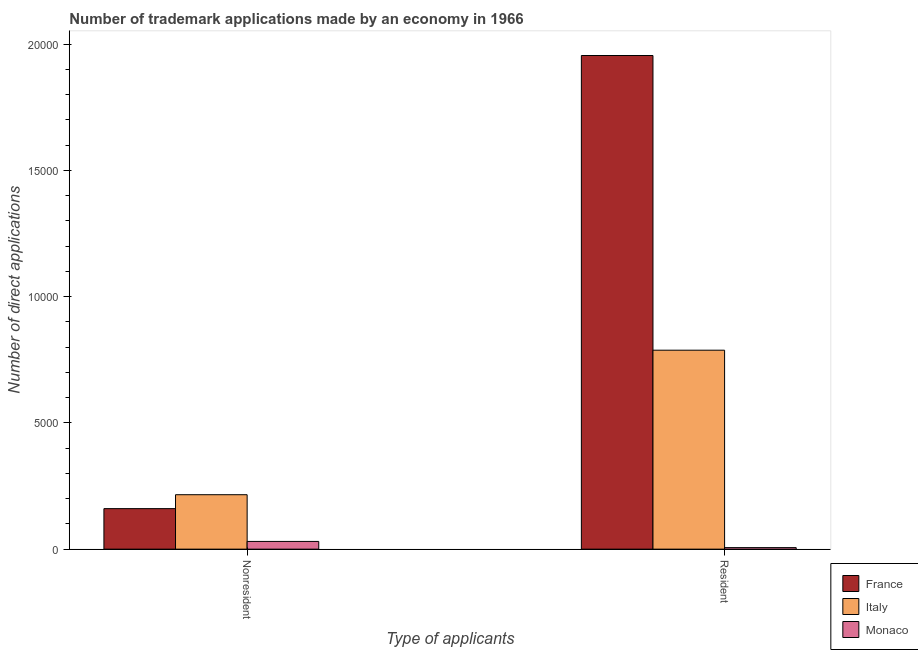How many different coloured bars are there?
Ensure brevity in your answer.  3. How many groups of bars are there?
Provide a short and direct response. 2. Are the number of bars on each tick of the X-axis equal?
Offer a very short reply. Yes. What is the label of the 1st group of bars from the left?
Give a very brief answer. Nonresident. What is the number of trademark applications made by non residents in Monaco?
Give a very brief answer. 306. Across all countries, what is the maximum number of trademark applications made by residents?
Make the answer very short. 1.96e+04. Across all countries, what is the minimum number of trademark applications made by non residents?
Give a very brief answer. 306. In which country was the number of trademark applications made by residents maximum?
Keep it short and to the point. France. In which country was the number of trademark applications made by non residents minimum?
Provide a short and direct response. Monaco. What is the total number of trademark applications made by residents in the graph?
Provide a short and direct response. 2.75e+04. What is the difference between the number of trademark applications made by non residents in France and that in Monaco?
Give a very brief answer. 1299. What is the difference between the number of trademark applications made by residents in Italy and the number of trademark applications made by non residents in Monaco?
Offer a terse response. 7574. What is the average number of trademark applications made by non residents per country?
Make the answer very short. 1355.67. What is the difference between the number of trademark applications made by residents and number of trademark applications made by non residents in Monaco?
Your answer should be compact. -245. What is the ratio of the number of trademark applications made by non residents in France to that in Monaco?
Your answer should be compact. 5.25. Is the number of trademark applications made by non residents in France less than that in Italy?
Provide a short and direct response. Yes. What does the 1st bar from the right in Nonresident represents?
Provide a succinct answer. Monaco. Are all the bars in the graph horizontal?
Your answer should be very brief. No. How many countries are there in the graph?
Your answer should be compact. 3. What is the difference between two consecutive major ticks on the Y-axis?
Offer a terse response. 5000. Are the values on the major ticks of Y-axis written in scientific E-notation?
Your answer should be very brief. No. Does the graph contain any zero values?
Your answer should be very brief. No. What is the title of the graph?
Your response must be concise. Number of trademark applications made by an economy in 1966. Does "Other small states" appear as one of the legend labels in the graph?
Make the answer very short. No. What is the label or title of the X-axis?
Make the answer very short. Type of applicants. What is the label or title of the Y-axis?
Your response must be concise. Number of direct applications. What is the Number of direct applications in France in Nonresident?
Offer a very short reply. 1605. What is the Number of direct applications of Italy in Nonresident?
Provide a short and direct response. 2156. What is the Number of direct applications of Monaco in Nonresident?
Keep it short and to the point. 306. What is the Number of direct applications of France in Resident?
Provide a short and direct response. 1.96e+04. What is the Number of direct applications in Italy in Resident?
Provide a short and direct response. 7880. Across all Type of applicants, what is the maximum Number of direct applications in France?
Give a very brief answer. 1.96e+04. Across all Type of applicants, what is the maximum Number of direct applications in Italy?
Your answer should be compact. 7880. Across all Type of applicants, what is the maximum Number of direct applications of Monaco?
Offer a very short reply. 306. Across all Type of applicants, what is the minimum Number of direct applications of France?
Provide a succinct answer. 1605. Across all Type of applicants, what is the minimum Number of direct applications in Italy?
Your answer should be compact. 2156. Across all Type of applicants, what is the minimum Number of direct applications of Monaco?
Offer a very short reply. 61. What is the total Number of direct applications in France in the graph?
Provide a short and direct response. 2.12e+04. What is the total Number of direct applications in Italy in the graph?
Your answer should be very brief. 1.00e+04. What is the total Number of direct applications of Monaco in the graph?
Your response must be concise. 367. What is the difference between the Number of direct applications in France in Nonresident and that in Resident?
Offer a very short reply. -1.79e+04. What is the difference between the Number of direct applications of Italy in Nonresident and that in Resident?
Your answer should be very brief. -5724. What is the difference between the Number of direct applications of Monaco in Nonresident and that in Resident?
Keep it short and to the point. 245. What is the difference between the Number of direct applications in France in Nonresident and the Number of direct applications in Italy in Resident?
Give a very brief answer. -6275. What is the difference between the Number of direct applications in France in Nonresident and the Number of direct applications in Monaco in Resident?
Offer a terse response. 1544. What is the difference between the Number of direct applications of Italy in Nonresident and the Number of direct applications of Monaco in Resident?
Offer a terse response. 2095. What is the average Number of direct applications of France per Type of applicants?
Provide a succinct answer. 1.06e+04. What is the average Number of direct applications of Italy per Type of applicants?
Provide a short and direct response. 5018. What is the average Number of direct applications of Monaco per Type of applicants?
Ensure brevity in your answer.  183.5. What is the difference between the Number of direct applications of France and Number of direct applications of Italy in Nonresident?
Make the answer very short. -551. What is the difference between the Number of direct applications of France and Number of direct applications of Monaco in Nonresident?
Keep it short and to the point. 1299. What is the difference between the Number of direct applications in Italy and Number of direct applications in Monaco in Nonresident?
Offer a terse response. 1850. What is the difference between the Number of direct applications in France and Number of direct applications in Italy in Resident?
Provide a succinct answer. 1.17e+04. What is the difference between the Number of direct applications in France and Number of direct applications in Monaco in Resident?
Give a very brief answer. 1.95e+04. What is the difference between the Number of direct applications of Italy and Number of direct applications of Monaco in Resident?
Offer a very short reply. 7819. What is the ratio of the Number of direct applications in France in Nonresident to that in Resident?
Offer a terse response. 0.08. What is the ratio of the Number of direct applications in Italy in Nonresident to that in Resident?
Give a very brief answer. 0.27. What is the ratio of the Number of direct applications of Monaco in Nonresident to that in Resident?
Make the answer very short. 5.02. What is the difference between the highest and the second highest Number of direct applications in France?
Your response must be concise. 1.79e+04. What is the difference between the highest and the second highest Number of direct applications of Italy?
Provide a short and direct response. 5724. What is the difference between the highest and the second highest Number of direct applications of Monaco?
Provide a short and direct response. 245. What is the difference between the highest and the lowest Number of direct applications of France?
Provide a short and direct response. 1.79e+04. What is the difference between the highest and the lowest Number of direct applications of Italy?
Offer a terse response. 5724. What is the difference between the highest and the lowest Number of direct applications of Monaco?
Provide a succinct answer. 245. 